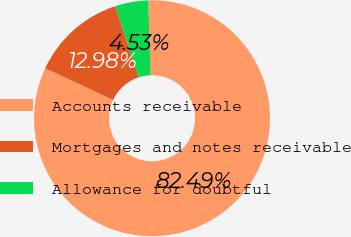Convert chart to OTSL. <chart><loc_0><loc_0><loc_500><loc_500><pie_chart><fcel>Accounts receivable<fcel>Mortgages and notes receivable<fcel>Allowance for doubtful<nl><fcel>82.49%<fcel>12.98%<fcel>4.53%<nl></chart> 